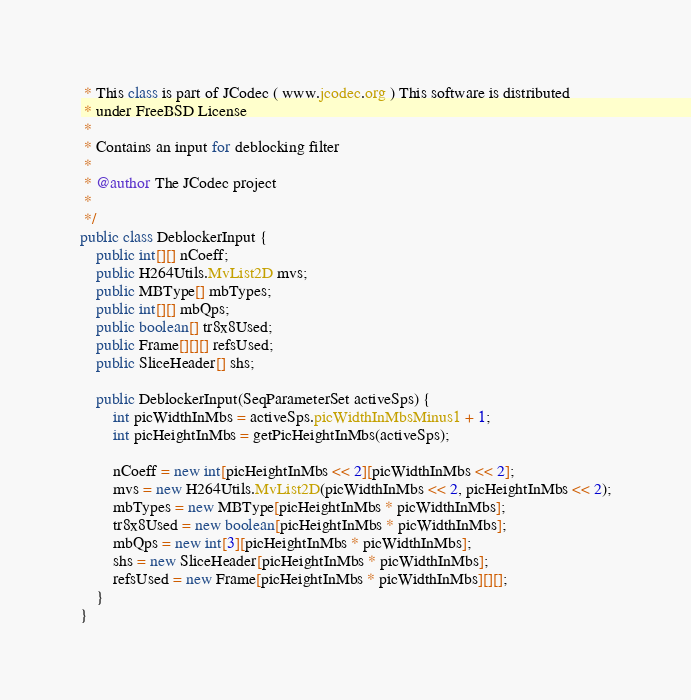Convert code to text. <code><loc_0><loc_0><loc_500><loc_500><_Java_> * This class is part of JCodec ( www.jcodec.org ) This software is distributed
 * under FreeBSD License
 *
 * Contains an input for deblocking filter
 * 
 * @author The JCodec project
 * 
 */
public class DeblockerInput {
    public int[][] nCoeff;
    public H264Utils.MvList2D mvs;
    public MBType[] mbTypes;
    public int[][] mbQps;
    public boolean[] tr8x8Used;
    public Frame[][][] refsUsed;
    public SliceHeader[] shs;

    public DeblockerInput(SeqParameterSet activeSps) {
        int picWidthInMbs = activeSps.picWidthInMbsMinus1 + 1;
        int picHeightInMbs = getPicHeightInMbs(activeSps);

        nCoeff = new int[picHeightInMbs << 2][picWidthInMbs << 2];
        mvs = new H264Utils.MvList2D(picWidthInMbs << 2, picHeightInMbs << 2);
        mbTypes = new MBType[picHeightInMbs * picWidthInMbs];
        tr8x8Used = new boolean[picHeightInMbs * picWidthInMbs];
        mbQps = new int[3][picHeightInMbs * picWidthInMbs];
        shs = new SliceHeader[picHeightInMbs * picWidthInMbs];
        refsUsed = new Frame[picHeightInMbs * picWidthInMbs][][];
    }
}
</code> 